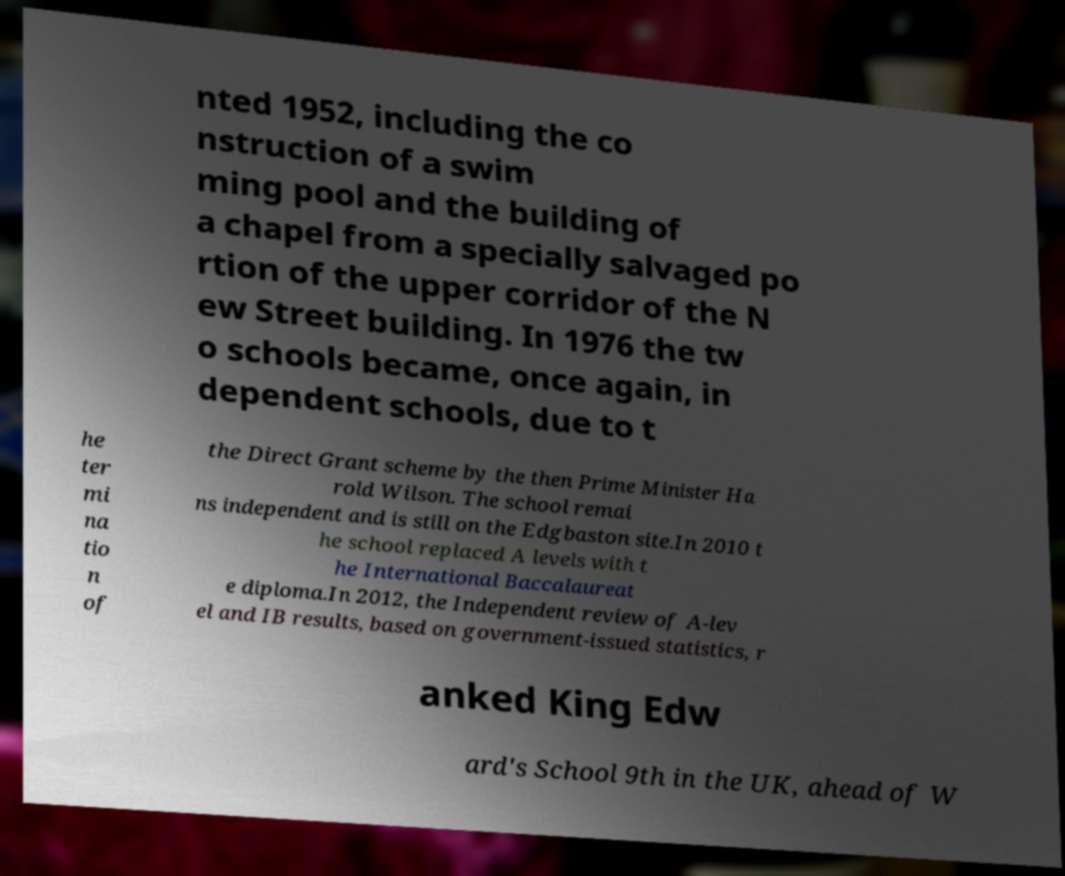There's text embedded in this image that I need extracted. Can you transcribe it verbatim? nted 1952, including the co nstruction of a swim ming pool and the building of a chapel from a specially salvaged po rtion of the upper corridor of the N ew Street building. In 1976 the tw o schools became, once again, in dependent schools, due to t he ter mi na tio n of the Direct Grant scheme by the then Prime Minister Ha rold Wilson. The school remai ns independent and is still on the Edgbaston site.In 2010 t he school replaced A levels with t he International Baccalaureat e diploma.In 2012, the Independent review of A-lev el and IB results, based on government-issued statistics, r anked King Edw ard's School 9th in the UK, ahead of W 